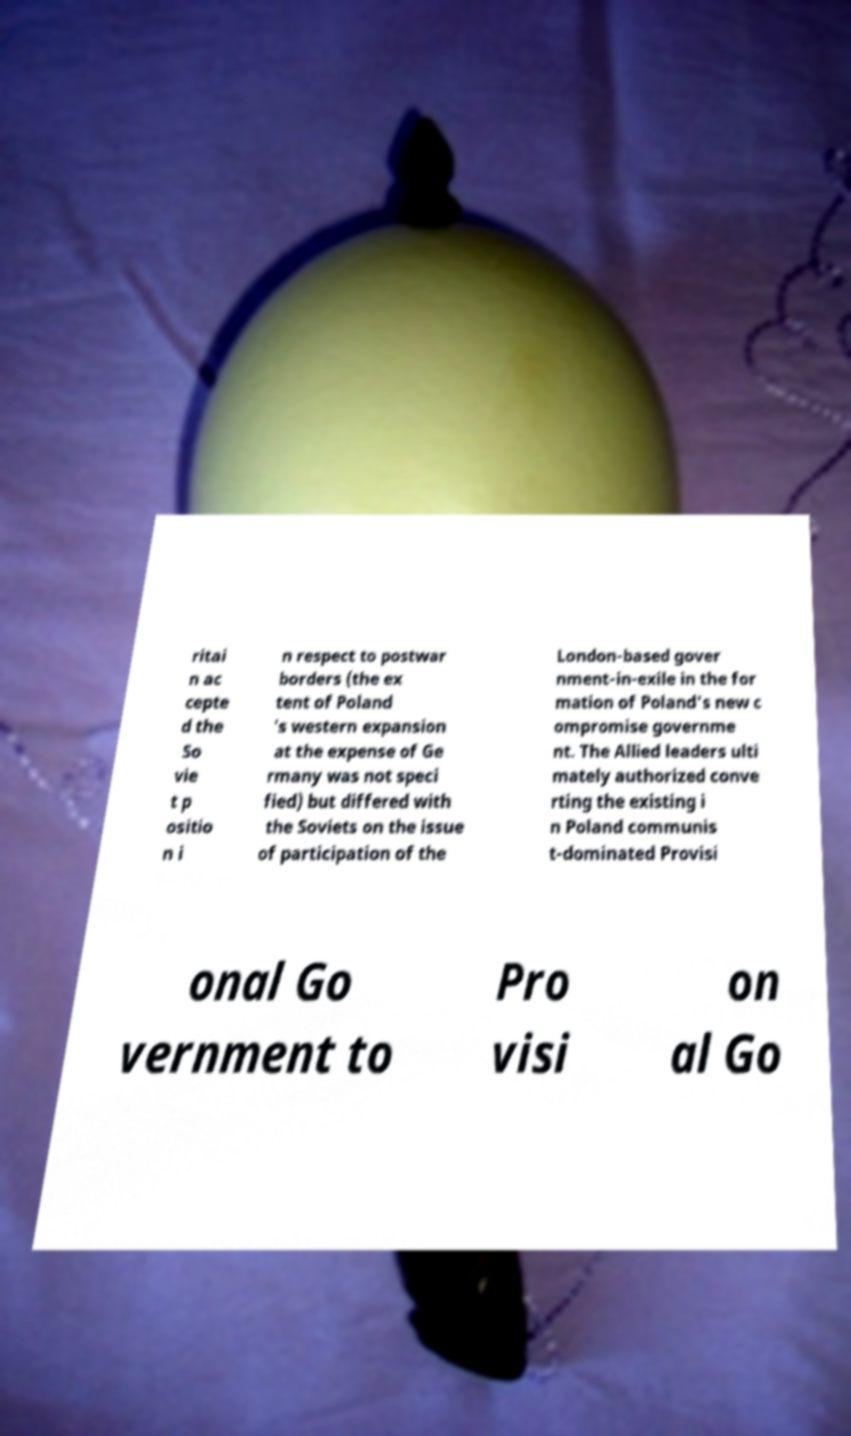Please read and relay the text visible in this image. What does it say? ritai n ac cepte d the So vie t p ositio n i n respect to postwar borders (the ex tent of Poland 's western expansion at the expense of Ge rmany was not speci fied) but differed with the Soviets on the issue of participation of the London-based gover nment-in-exile in the for mation of Poland's new c ompromise governme nt. The Allied leaders ulti mately authorized conve rting the existing i n Poland communis t-dominated Provisi onal Go vernment to Pro visi on al Go 